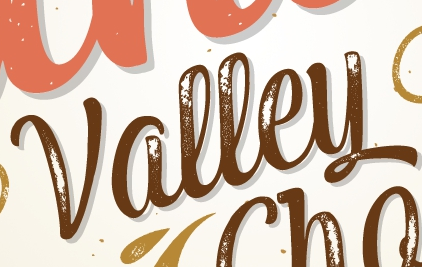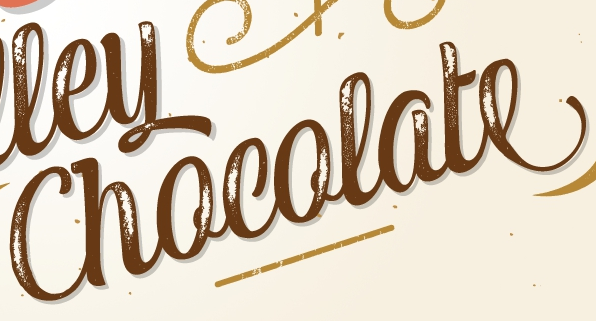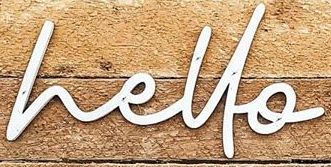What words are shown in these images in order, separated by a semicolon? Valley; Chocolate; hello 